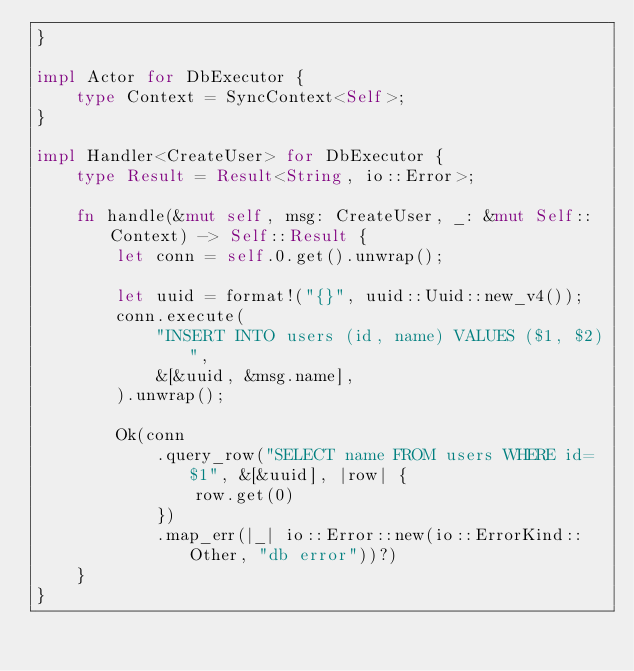<code> <loc_0><loc_0><loc_500><loc_500><_Rust_>}

impl Actor for DbExecutor {
    type Context = SyncContext<Self>;
}

impl Handler<CreateUser> for DbExecutor {
    type Result = Result<String, io::Error>;

    fn handle(&mut self, msg: CreateUser, _: &mut Self::Context) -> Self::Result {
        let conn = self.0.get().unwrap();

        let uuid = format!("{}", uuid::Uuid::new_v4());
        conn.execute(
            "INSERT INTO users (id, name) VALUES ($1, $2)",
            &[&uuid, &msg.name],
        ).unwrap();

        Ok(conn
            .query_row("SELECT name FROM users WHERE id=$1", &[&uuid], |row| {
                row.get(0)
            })
            .map_err(|_| io::Error::new(io::ErrorKind::Other, "db error"))?)
    }
}
</code> 